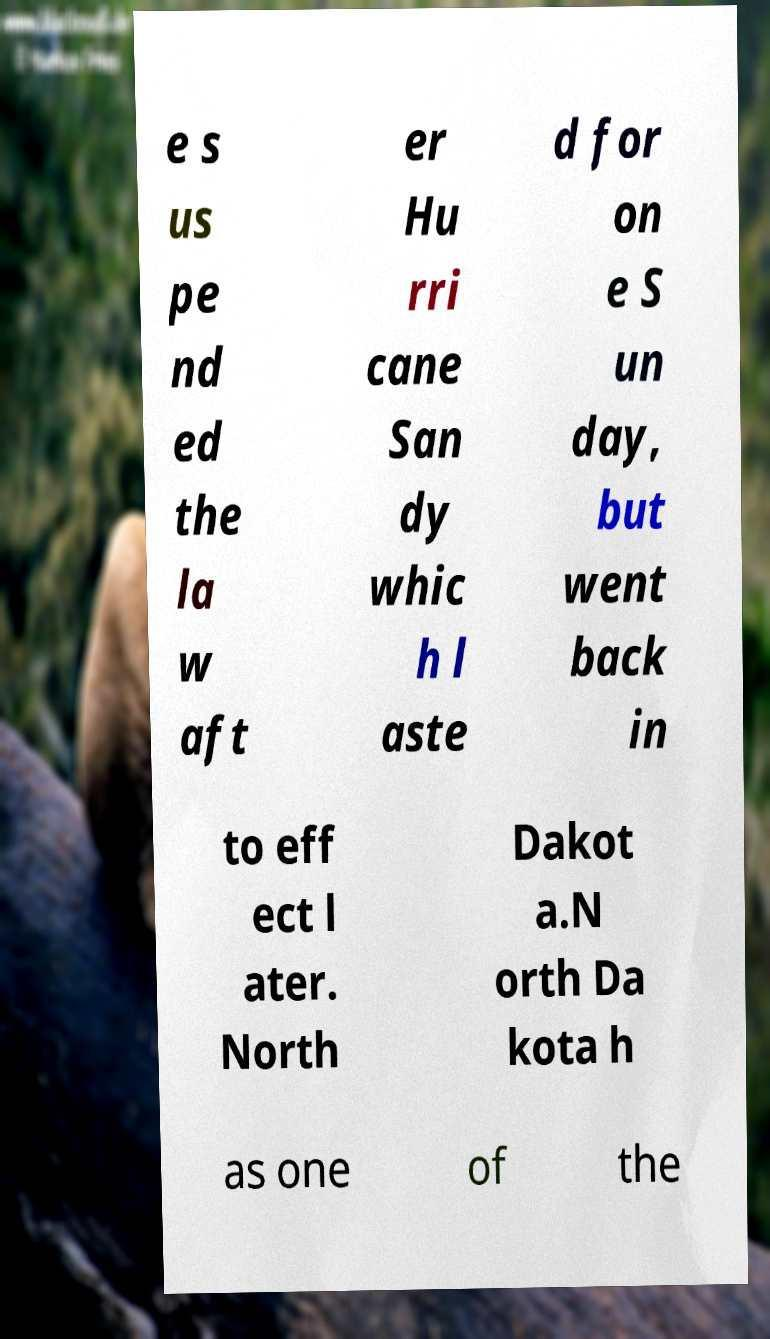Can you read and provide the text displayed in the image?This photo seems to have some interesting text. Can you extract and type it out for me? e s us pe nd ed the la w aft er Hu rri cane San dy whic h l aste d for on e S un day, but went back in to eff ect l ater. North Dakot a.N orth Da kota h as one of the 